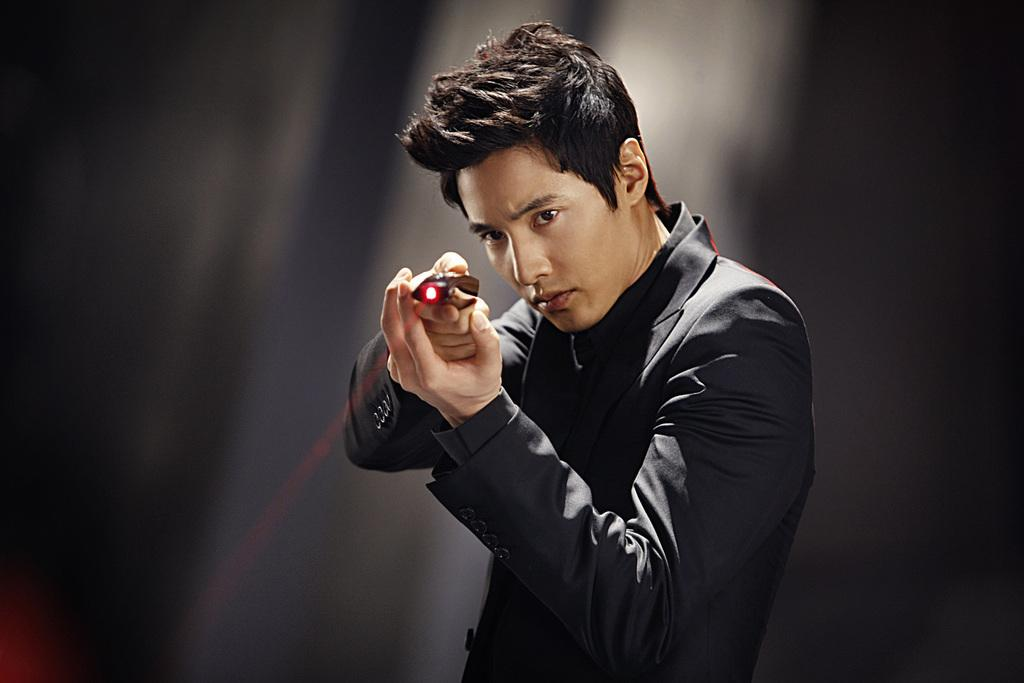What is the main subject of the image? There is a person standing in the center of the image. Can you describe the person's attire? The person is wearing a black costume. What is the person holding in the image? The person is holding an object. How would you describe the background of the image? The background of the image is blurred. What type of engine can be seen in the person's pocket in the image? There is no engine visible in the image, nor is there any indication that the person has a pocket. 